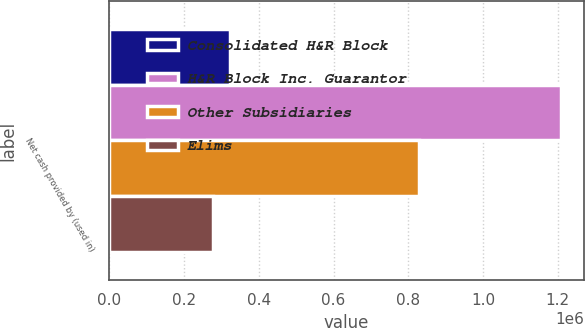Convert chart to OTSL. <chart><loc_0><loc_0><loc_500><loc_500><stacked_bar_chart><ecel><fcel>Net cash provided by (used in)<nl><fcel>Consolidated H&R Block<fcel>324088<nl><fcel>H&R Block Inc. Guarantor<fcel>1.20913e+06<nl><fcel>Other Subsidiaries<fcel>829617<nl><fcel>Elims<fcel>276450<nl></chart> 